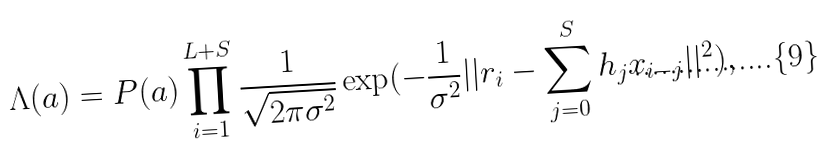<formula> <loc_0><loc_0><loc_500><loc_500>\Lambda ( { a } ) = P ( { a } ) \prod _ { i = 1 } ^ { L + S } \frac { 1 } { \sqrt { 2 \pi \sigma ^ { 2 } } } \exp ( - \frac { 1 } { \sigma ^ { 2 } } | | r _ { i } - \sum _ { j = 0 } ^ { S } h _ { j } x _ { i - j } | | ^ { 2 } ) ,</formula> 